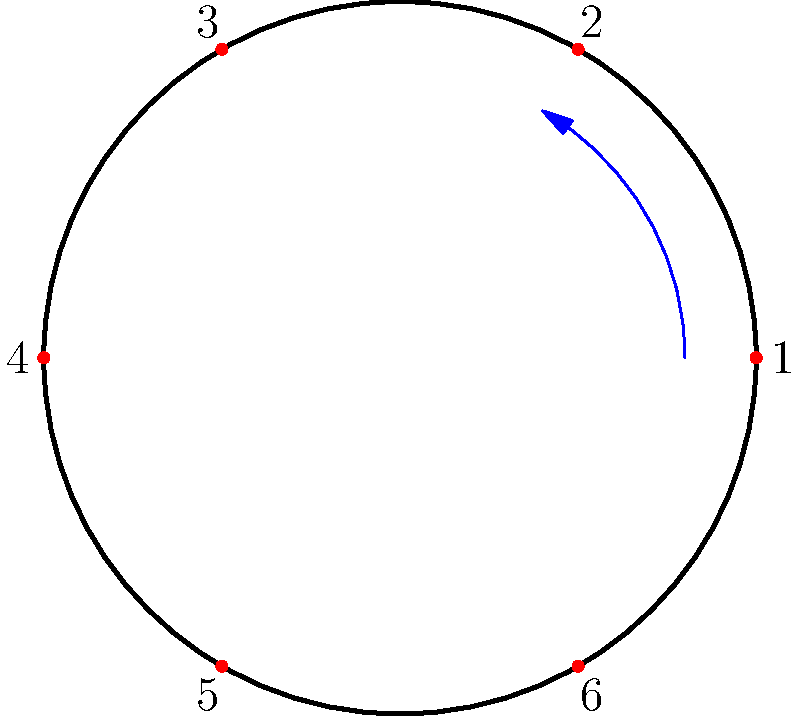A retro chocolate wrapper features a circular pattern with 6 evenly spaced dots, numbered 1 to 6 clockwise. The wrapper can be rotated, and each rotation moves every dot to the next position clockwise. How many rotations are needed to return the wrapper to its original position, and what is the order of the cyclic group represented by these rotations? Let's approach this step-by-step:

1) First, we need to understand what each rotation does:
   - A single rotation moves each dot one position clockwise.
   - For example, after one rotation: 1 → 2, 2 → 3, 3 → 4, 4 → 5, 5 → 6, 6 → 1

2) To find how many rotations are needed to return to the original position:
   - We need to rotate until dot 1 returns to its original position.
   - This will happen after 6 rotations because there are 6 positions.

3) Each rotation can be considered as an element of a cyclic group:
   - Let's call the rotation operation $r$.
   - The identity element $e$ is no rotation (or 6 rotations).
   - We can represent the group as $\{e, r, r^2, r^3, r^4, r^5\}$.

4) The order of a cyclic group is the number of elements in the group:
   - In this case, there are 6 distinct rotations (including the identity).

5) Therefore, this pattern represents a cyclic group of order 6, often denoted as $C_6$ or $\mathbb{Z}_6$.

This group is isomorphic to the additive group of integers modulo 6, which Jimmy might remember from the way clock arithmetic works!
Answer: 6 rotations; order 6 